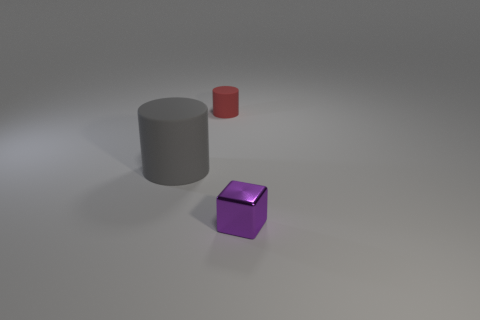Add 2 big green cylinders. How many objects exist? 5 Subtract all cylinders. How many objects are left? 1 Add 2 small purple things. How many small purple things exist? 3 Subtract 0 blue blocks. How many objects are left? 3 Subtract all purple cubes. Subtract all gray matte things. How many objects are left? 1 Add 2 tiny red cylinders. How many tiny red cylinders are left? 3 